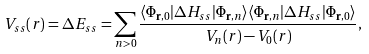Convert formula to latex. <formula><loc_0><loc_0><loc_500><loc_500>V _ { s s } ( r ) = \Delta E _ { s s } = \sum _ { n > 0 } \frac { \langle \Phi _ { { \mathbf r } , 0 } | \Delta H _ { s s } | \Phi _ { { \mathbf r } , n } \rangle \langle \Phi _ { { \mathbf r } , n } | \Delta H _ { s s } | \Phi _ { { \mathbf r } , 0 } \rangle } { V _ { n } ( r ) - V _ { 0 } ( r ) } ,</formula> 